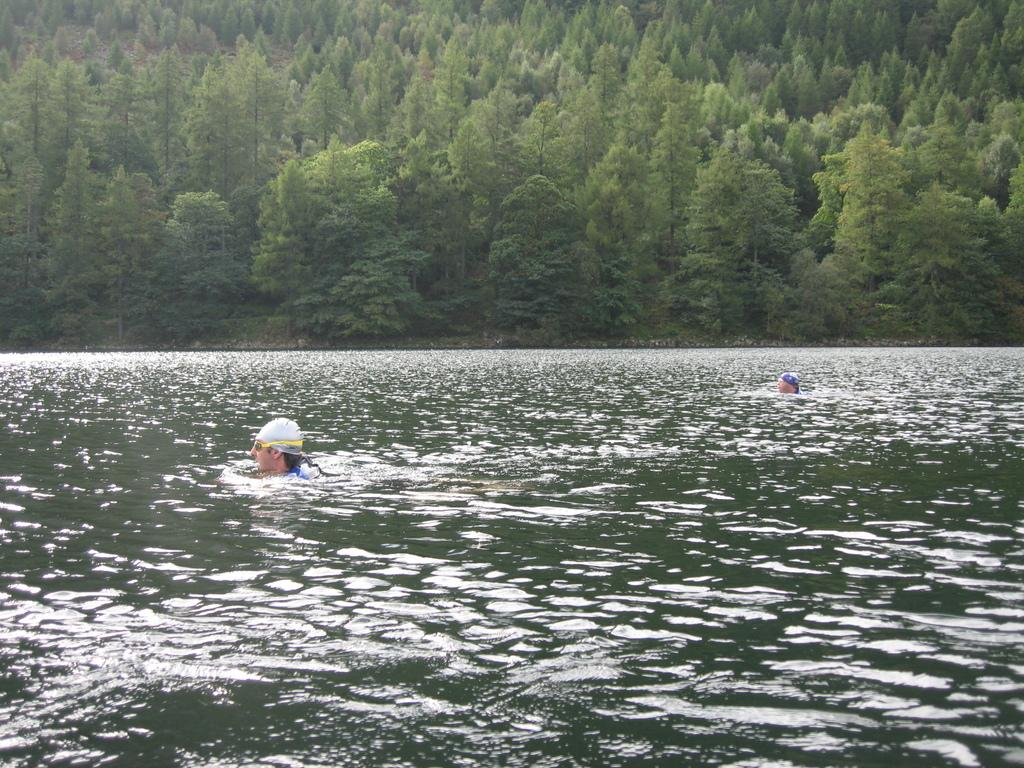How many people are in the water in the image? There are two people in the water in the image. What can be seen in the background of the image? There are trees in the background of the image. What is the account balance of the person in the water? There is no information about an account balance in the image, as it features two people in the water and trees in the background. 